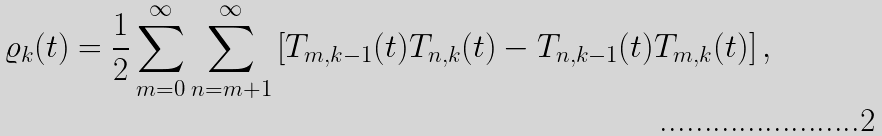<formula> <loc_0><loc_0><loc_500><loc_500>\varrho _ { k } ( t ) = \frac { 1 } { 2 } \sum _ { m = 0 } ^ { \infty } \sum _ { n = m + 1 } ^ { \infty } \left [ T _ { m , k - 1 } ( t ) T _ { n , k } ( t ) - T _ { n , k - 1 } ( t ) T _ { m , k } ( t ) \right ] ,</formula> 